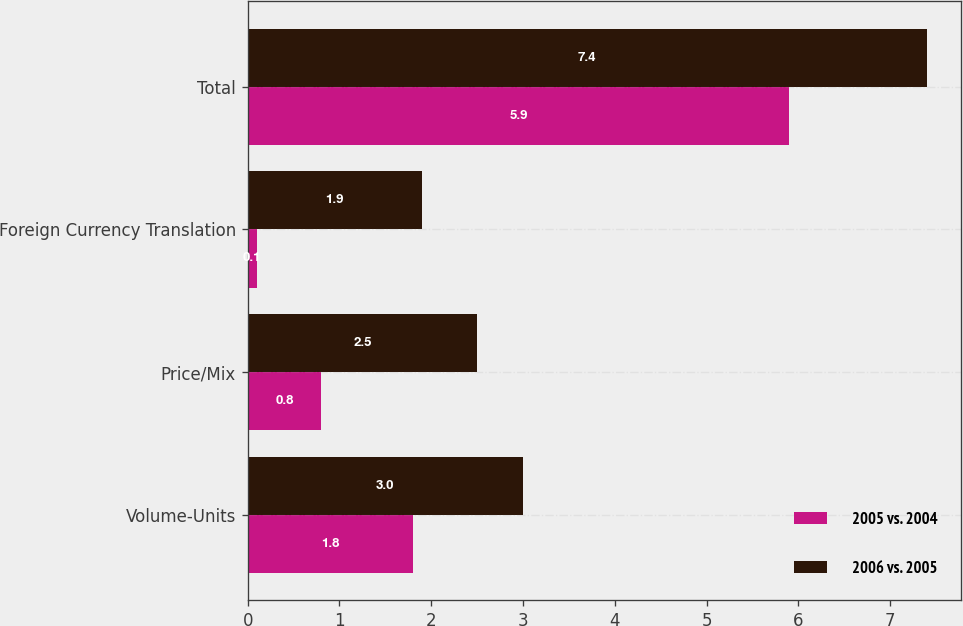Convert chart. <chart><loc_0><loc_0><loc_500><loc_500><stacked_bar_chart><ecel><fcel>Volume-Units<fcel>Price/Mix<fcel>Foreign Currency Translation<fcel>Total<nl><fcel>2005 vs. 2004<fcel>1.8<fcel>0.8<fcel>0.1<fcel>5.9<nl><fcel>2006 vs. 2005<fcel>3<fcel>2.5<fcel>1.9<fcel>7.4<nl></chart> 